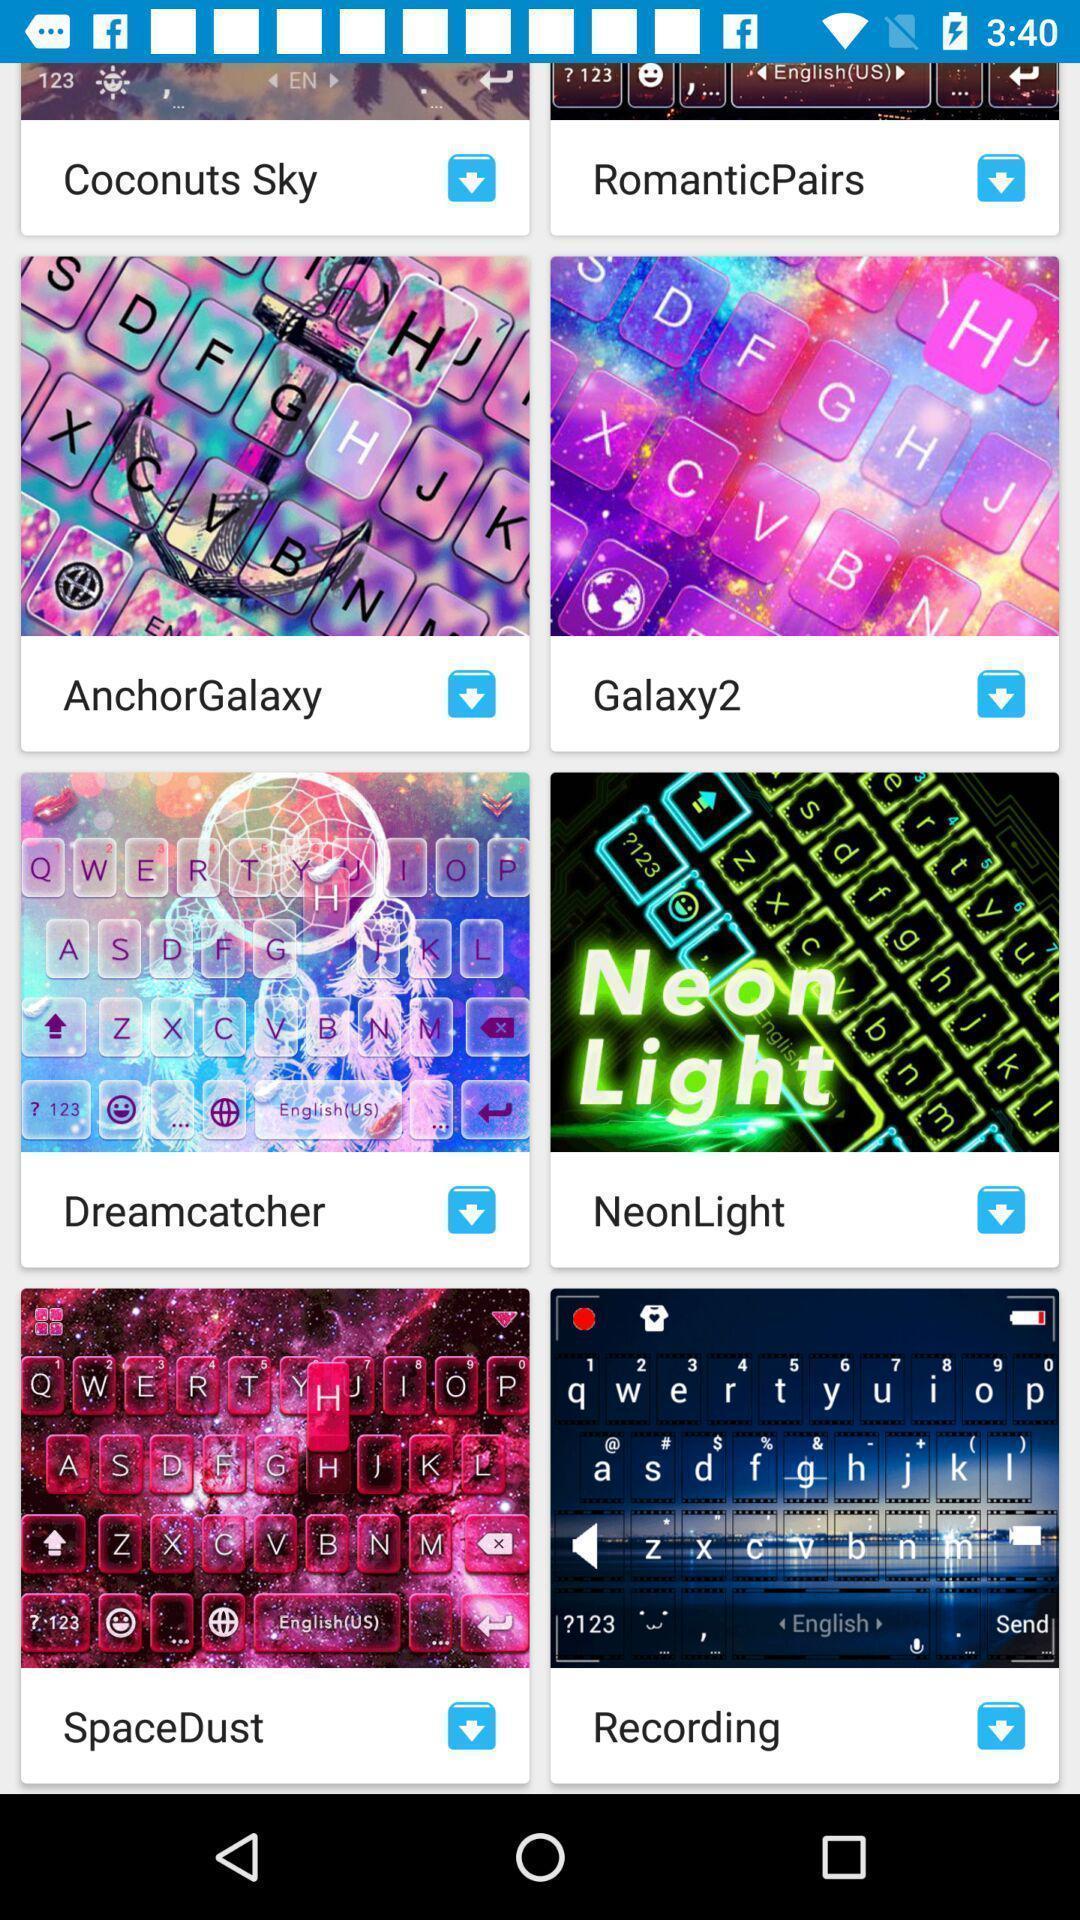Describe the content in this image. Screen displaying different kinds of themes. 